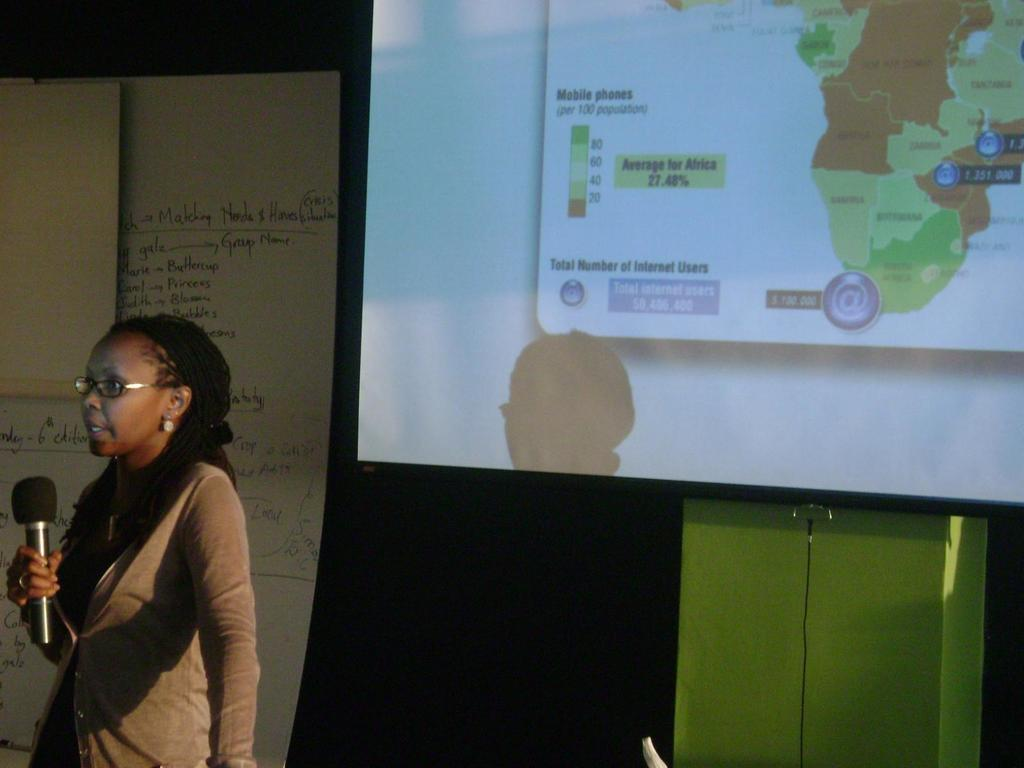What is the main subject of the image? There is a woman in the image. What is the woman doing in the image? The woman is standing and speaking in the image. What is the woman holding in the image? The woman is holding a microphone in the image. What can be seen in the background of the image? There is a screen in the background of the image. What is on the left side of the image? There is a sheet on the left side of the image. What type of wood is used to support the screen in the image? There is no wood visible in the image, and the screen's support is not mentioned in the facts provided. 